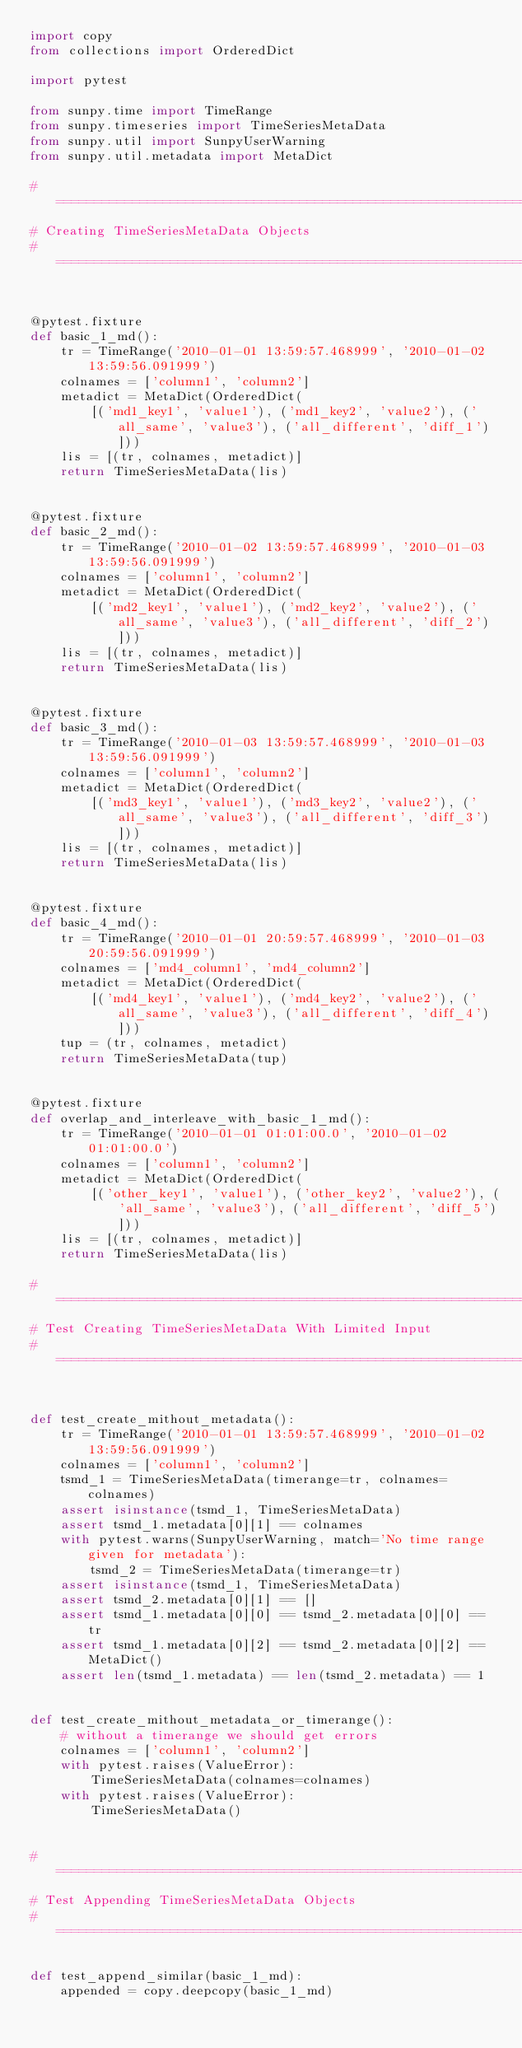Convert code to text. <code><loc_0><loc_0><loc_500><loc_500><_Python_>import copy
from collections import OrderedDict

import pytest

from sunpy.time import TimeRange
from sunpy.timeseries import TimeSeriesMetaData
from sunpy.util import SunpyUserWarning
from sunpy.util.metadata import MetaDict

# =============================================================================
# Creating TimeSeriesMetaData Objects
# =============================================================================


@pytest.fixture
def basic_1_md():
    tr = TimeRange('2010-01-01 13:59:57.468999', '2010-01-02 13:59:56.091999')
    colnames = ['column1', 'column2']
    metadict = MetaDict(OrderedDict(
        [('md1_key1', 'value1'), ('md1_key2', 'value2'), ('all_same', 'value3'), ('all_different', 'diff_1')]))
    lis = [(tr, colnames, metadict)]
    return TimeSeriesMetaData(lis)


@pytest.fixture
def basic_2_md():
    tr = TimeRange('2010-01-02 13:59:57.468999', '2010-01-03 13:59:56.091999')
    colnames = ['column1', 'column2']
    metadict = MetaDict(OrderedDict(
        [('md2_key1', 'value1'), ('md2_key2', 'value2'), ('all_same', 'value3'), ('all_different', 'diff_2')]))
    lis = [(tr, colnames, metadict)]
    return TimeSeriesMetaData(lis)


@pytest.fixture
def basic_3_md():
    tr = TimeRange('2010-01-03 13:59:57.468999', '2010-01-03 13:59:56.091999')
    colnames = ['column1', 'column2']
    metadict = MetaDict(OrderedDict(
        [('md3_key1', 'value1'), ('md3_key2', 'value2'), ('all_same', 'value3'), ('all_different', 'diff_3')]))
    lis = [(tr, colnames, metadict)]
    return TimeSeriesMetaData(lis)


@pytest.fixture
def basic_4_md():
    tr = TimeRange('2010-01-01 20:59:57.468999', '2010-01-03 20:59:56.091999')
    colnames = ['md4_column1', 'md4_column2']
    metadict = MetaDict(OrderedDict(
        [('md4_key1', 'value1'), ('md4_key2', 'value2'), ('all_same', 'value3'), ('all_different', 'diff_4')]))
    tup = (tr, colnames, metadict)
    return TimeSeriesMetaData(tup)


@pytest.fixture
def overlap_and_interleave_with_basic_1_md():
    tr = TimeRange('2010-01-01 01:01:00.0', '2010-01-02 01:01:00.0')
    colnames = ['column1', 'column2']
    metadict = MetaDict(OrderedDict(
        [('other_key1', 'value1'), ('other_key2', 'value2'), ('all_same', 'value3'), ('all_different', 'diff_5')]))
    lis = [(tr, colnames, metadict)]
    return TimeSeriesMetaData(lis)

# =============================================================================
# Test Creating TimeSeriesMetaData With Limited Input
# =============================================================================


def test_create_mithout_metadata():
    tr = TimeRange('2010-01-01 13:59:57.468999', '2010-01-02 13:59:56.091999')
    colnames = ['column1', 'column2']
    tsmd_1 = TimeSeriesMetaData(timerange=tr, colnames=colnames)
    assert isinstance(tsmd_1, TimeSeriesMetaData)
    assert tsmd_1.metadata[0][1] == colnames
    with pytest.warns(SunpyUserWarning, match='No time range given for metadata'):
        tsmd_2 = TimeSeriesMetaData(timerange=tr)
    assert isinstance(tsmd_1, TimeSeriesMetaData)
    assert tsmd_2.metadata[0][1] == []
    assert tsmd_1.metadata[0][0] == tsmd_2.metadata[0][0] == tr
    assert tsmd_1.metadata[0][2] == tsmd_2.metadata[0][2] == MetaDict()
    assert len(tsmd_1.metadata) == len(tsmd_2.metadata) == 1


def test_create_mithout_metadata_or_timerange():
    # without a timerange we should get errors
    colnames = ['column1', 'column2']
    with pytest.raises(ValueError):
        TimeSeriesMetaData(colnames=colnames)
    with pytest.raises(ValueError):
        TimeSeriesMetaData()


# =============================================================================
# Test Appending TimeSeriesMetaData Objects
# =============================================================================

def test_append_similar(basic_1_md):
    appended = copy.deepcopy(basic_1_md)</code> 